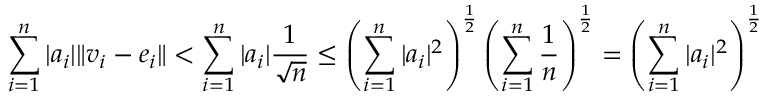<formula> <loc_0><loc_0><loc_500><loc_500>\sum _ { i = 1 } ^ { n } | a _ { i } | \| v _ { i } - e _ { i } \| < \sum _ { i = 1 } ^ { n } | a _ { i } | \frac { 1 } { \sqrt { n } } \leq \left ( \sum _ { i = 1 } ^ { n } | a _ { i } | ^ { 2 } \right ) ^ { \frac { 1 } { 2 } } \left ( \sum _ { i = 1 } ^ { n } \frac { 1 } { n } \right ) ^ { \frac { 1 } { 2 } } = \left ( \sum _ { i = 1 } ^ { n } | a _ { i } | ^ { 2 } \right ) ^ { \frac { 1 } { 2 } }</formula> 